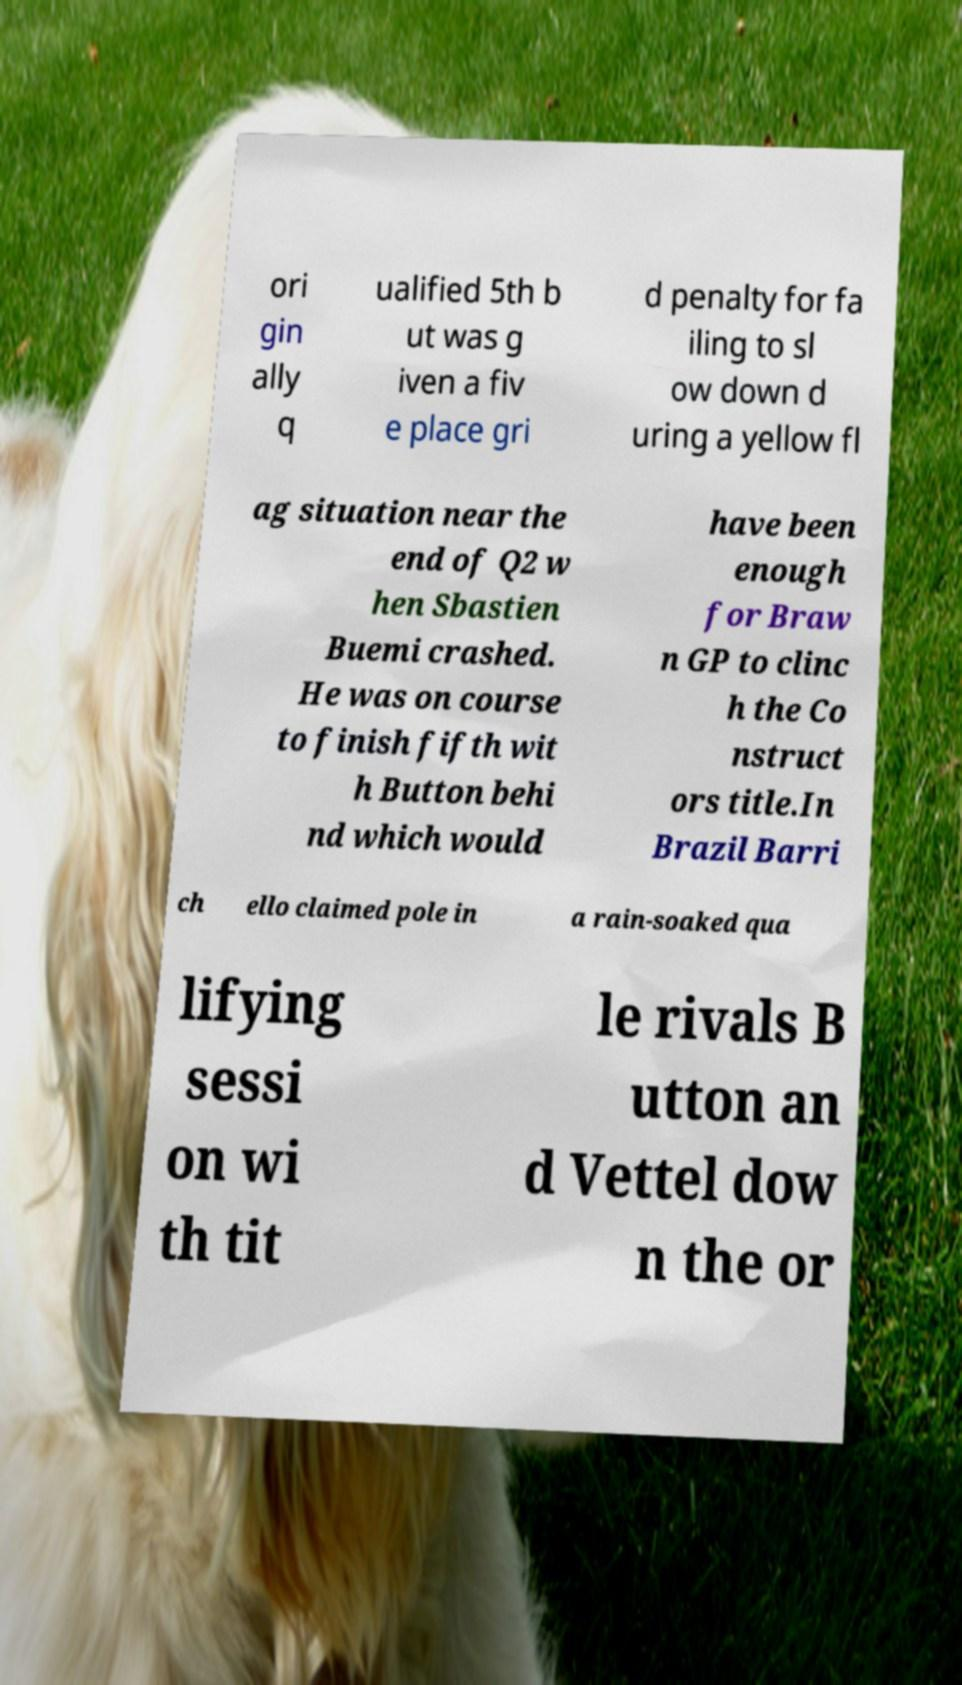Please read and relay the text visible in this image. What does it say? ori gin ally q ualified 5th b ut was g iven a fiv e place gri d penalty for fa iling to sl ow down d uring a yellow fl ag situation near the end of Q2 w hen Sbastien Buemi crashed. He was on course to finish fifth wit h Button behi nd which would have been enough for Braw n GP to clinc h the Co nstruct ors title.In Brazil Barri ch ello claimed pole in a rain-soaked qua lifying sessi on wi th tit le rivals B utton an d Vettel dow n the or 